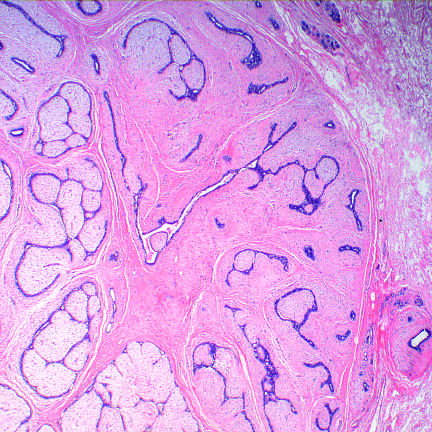what does this benign tumor have?
Answer the question using a single word or phrase. An expansile growth pattern with pushing circumscribed borders 